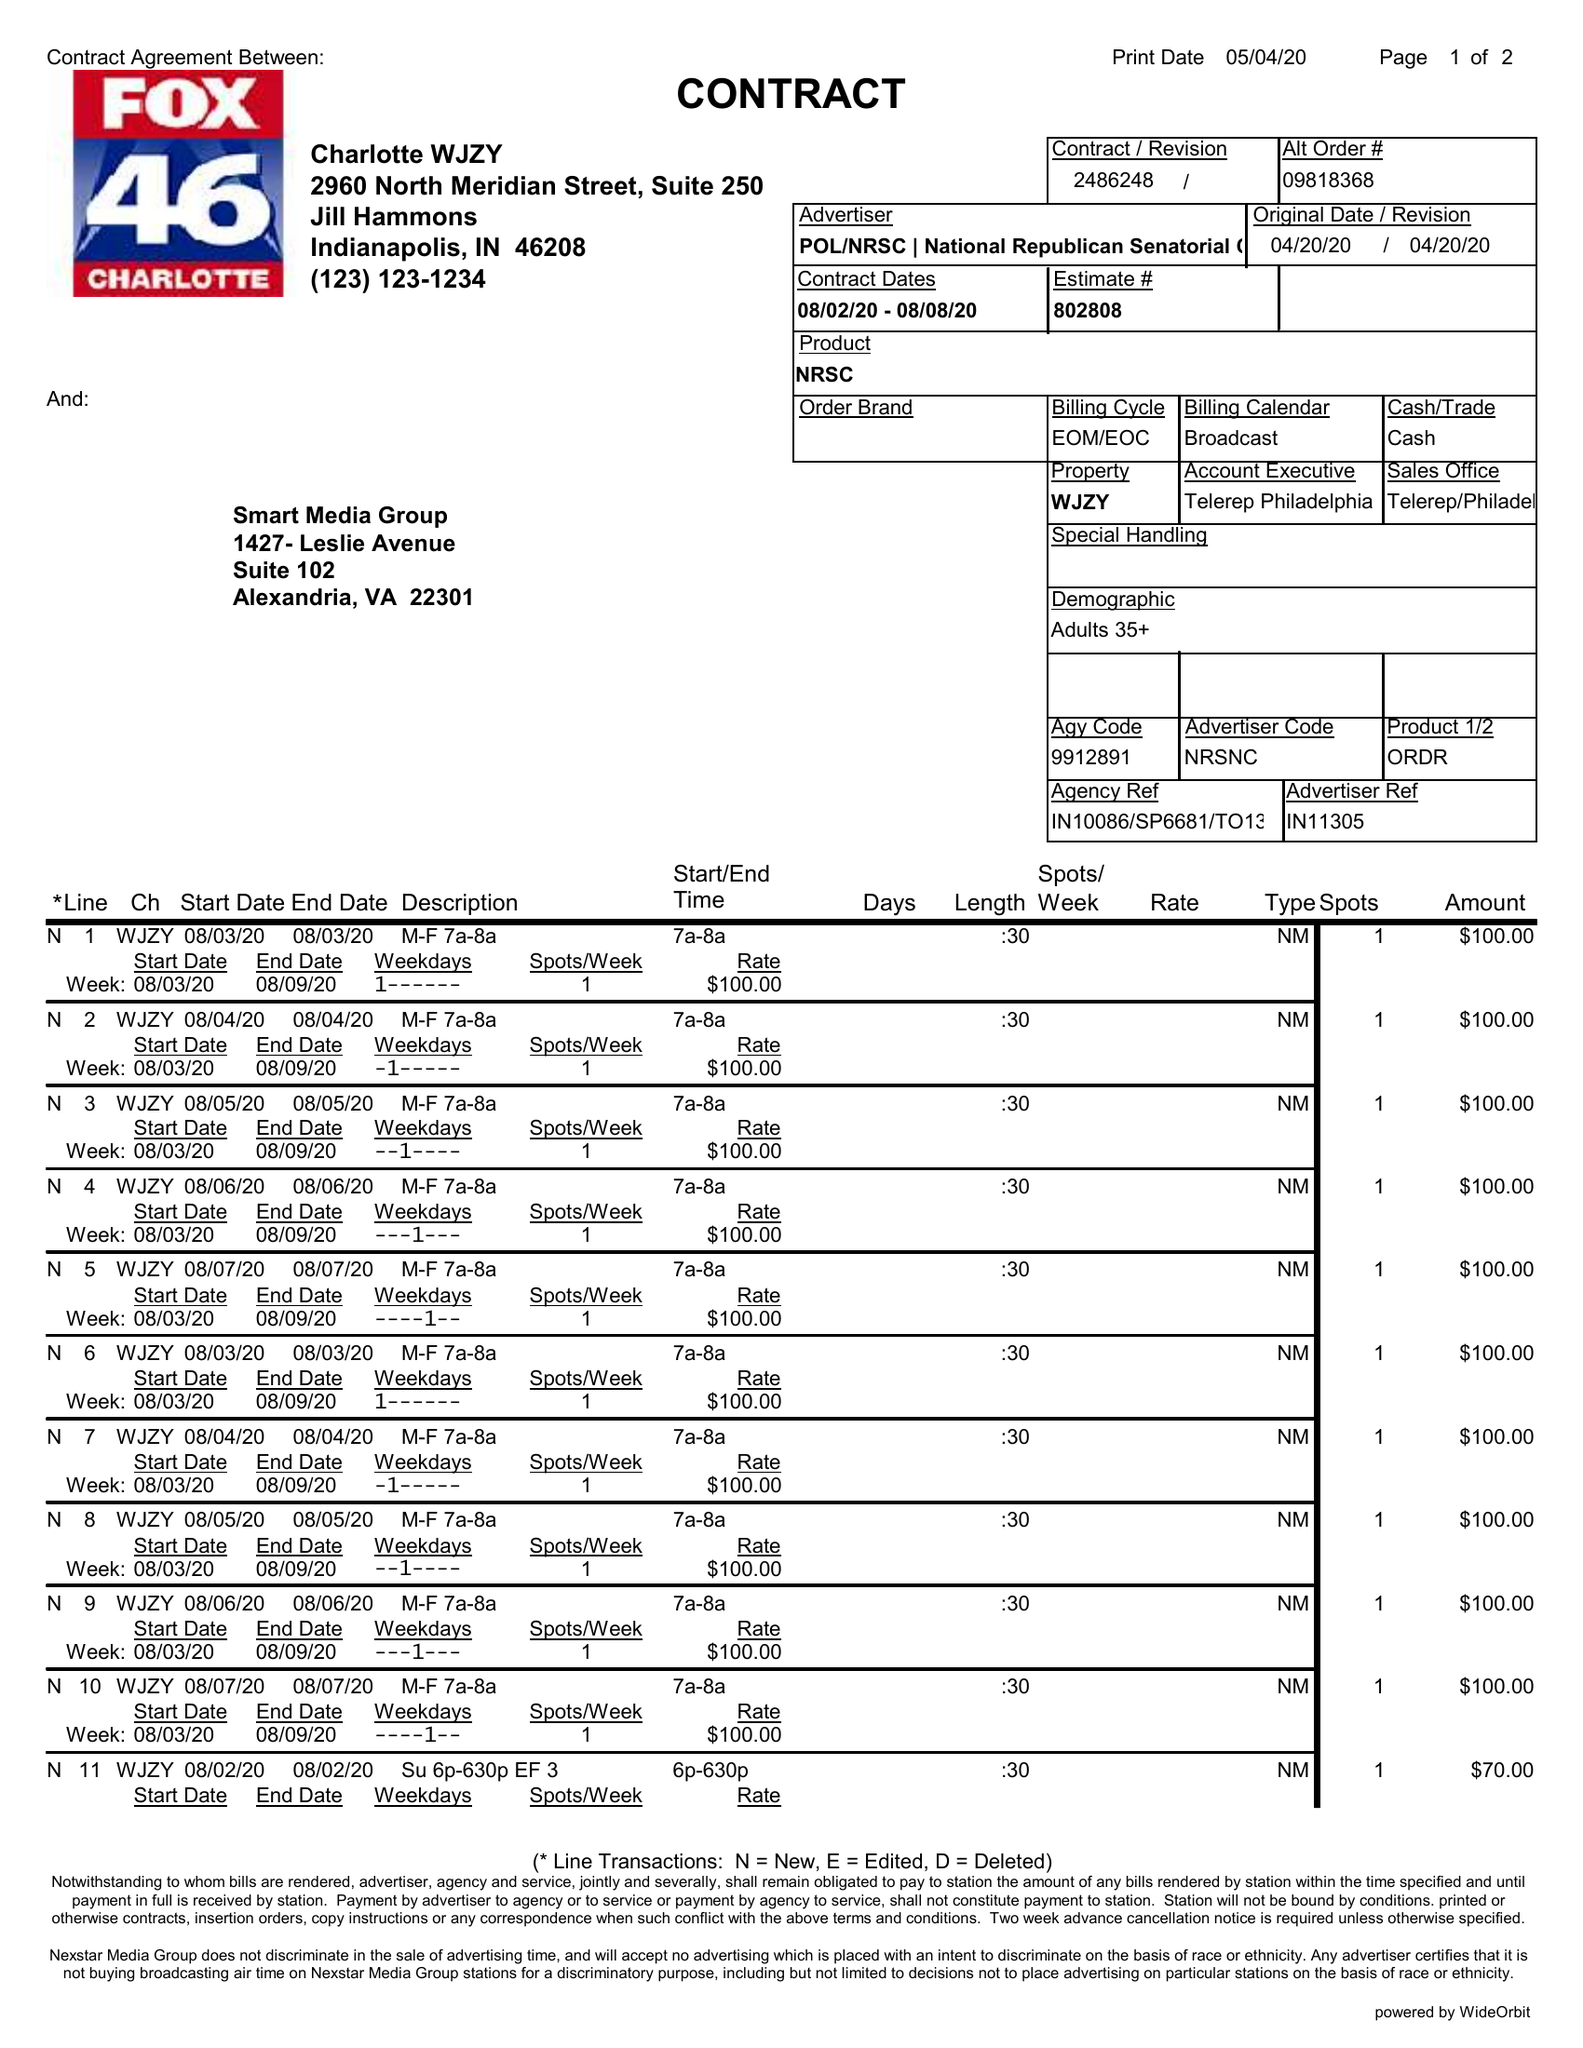What is the value for the advertiser?
Answer the question using a single word or phrase. POL/NRSC|NATIONALREPUBLICANSENATORIALCOMM 